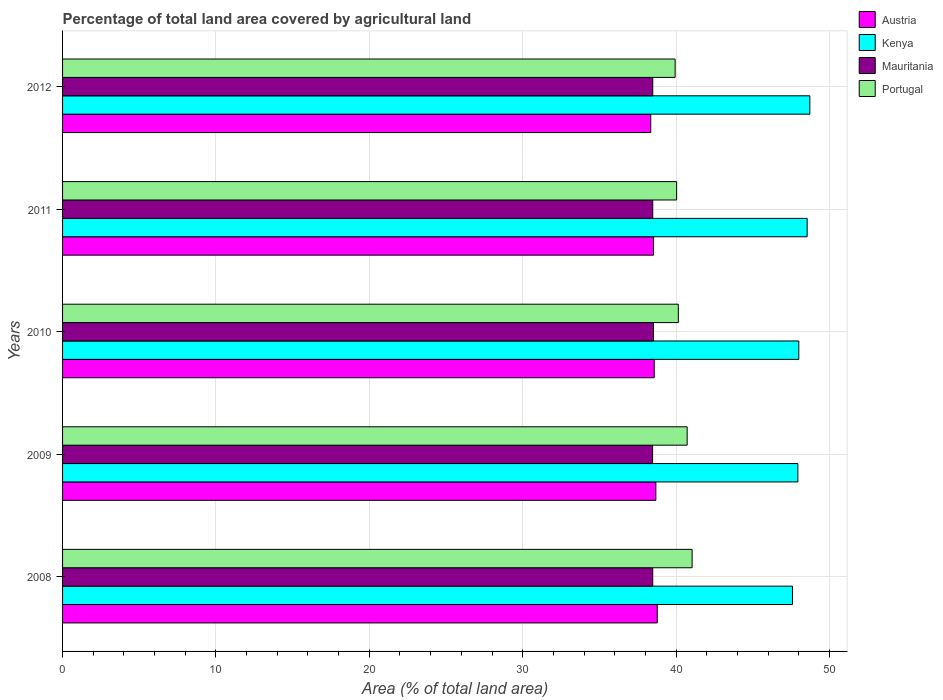How many groups of bars are there?
Provide a succinct answer. 5. How many bars are there on the 2nd tick from the top?
Your answer should be compact. 4. What is the label of the 2nd group of bars from the top?
Your answer should be very brief. 2011. What is the percentage of agricultural land in Mauritania in 2011?
Your answer should be compact. 38.48. Across all years, what is the maximum percentage of agricultural land in Austria?
Ensure brevity in your answer.  38.77. Across all years, what is the minimum percentage of agricultural land in Portugal?
Give a very brief answer. 39.94. In which year was the percentage of agricultural land in Austria minimum?
Keep it short and to the point. 2012. What is the total percentage of agricultural land in Mauritania in the graph?
Make the answer very short. 192.44. What is the difference between the percentage of agricultural land in Portugal in 2010 and that in 2012?
Make the answer very short. 0.21. What is the difference between the percentage of agricultural land in Kenya in 2008 and the percentage of agricultural land in Portugal in 2012?
Your answer should be very brief. 7.65. What is the average percentage of agricultural land in Portugal per year?
Offer a very short reply. 40.38. In the year 2012, what is the difference between the percentage of agricultural land in Portugal and percentage of agricultural land in Mauritania?
Make the answer very short. 1.46. In how many years, is the percentage of agricultural land in Portugal greater than 4 %?
Your response must be concise. 5. What is the ratio of the percentage of agricultural land in Kenya in 2010 to that in 2012?
Your answer should be compact. 0.99. Is the percentage of agricultural land in Austria in 2008 less than that in 2012?
Your response must be concise. No. Is the difference between the percentage of agricultural land in Portugal in 2008 and 2009 greater than the difference between the percentage of agricultural land in Mauritania in 2008 and 2009?
Provide a short and direct response. Yes. What is the difference between the highest and the second highest percentage of agricultural land in Mauritania?
Give a very brief answer. 0.05. What is the difference between the highest and the lowest percentage of agricultural land in Austria?
Your answer should be very brief. 0.42. Is the sum of the percentage of agricultural land in Austria in 2009 and 2011 greater than the maximum percentage of agricultural land in Mauritania across all years?
Provide a short and direct response. Yes. What does the 4th bar from the top in 2010 represents?
Provide a short and direct response. Austria. What does the 2nd bar from the bottom in 2009 represents?
Your answer should be compact. Kenya. What is the difference between two consecutive major ticks on the X-axis?
Offer a very short reply. 10. Are the values on the major ticks of X-axis written in scientific E-notation?
Your answer should be very brief. No. Does the graph contain any zero values?
Your response must be concise. No. How many legend labels are there?
Ensure brevity in your answer.  4. How are the legend labels stacked?
Make the answer very short. Vertical. What is the title of the graph?
Offer a terse response. Percentage of total land area covered by agricultural land. What is the label or title of the X-axis?
Provide a succinct answer. Area (% of total land area). What is the Area (% of total land area) in Austria in 2008?
Your answer should be compact. 38.77. What is the Area (% of total land area) in Kenya in 2008?
Keep it short and to the point. 47.59. What is the Area (% of total land area) in Mauritania in 2008?
Offer a very short reply. 38.48. What is the Area (% of total land area) in Portugal in 2008?
Keep it short and to the point. 41.05. What is the Area (% of total land area) of Austria in 2009?
Your answer should be very brief. 38.68. What is the Area (% of total land area) of Kenya in 2009?
Provide a succinct answer. 47.94. What is the Area (% of total land area) in Mauritania in 2009?
Give a very brief answer. 38.47. What is the Area (% of total land area) of Portugal in 2009?
Offer a very short reply. 40.72. What is the Area (% of total land area) of Austria in 2010?
Your answer should be very brief. 38.58. What is the Area (% of total land area) in Kenya in 2010?
Provide a short and direct response. 48. What is the Area (% of total land area) in Mauritania in 2010?
Provide a succinct answer. 38.53. What is the Area (% of total land area) of Portugal in 2010?
Provide a short and direct response. 40.15. What is the Area (% of total land area) in Austria in 2011?
Your response must be concise. 38.53. What is the Area (% of total land area) in Kenya in 2011?
Keep it short and to the point. 48.55. What is the Area (% of total land area) in Mauritania in 2011?
Keep it short and to the point. 38.48. What is the Area (% of total land area) of Portugal in 2011?
Offer a terse response. 40.04. What is the Area (% of total land area) of Austria in 2012?
Make the answer very short. 38.35. What is the Area (% of total land area) in Kenya in 2012?
Make the answer very short. 48.72. What is the Area (% of total land area) of Mauritania in 2012?
Your answer should be compact. 38.48. What is the Area (% of total land area) in Portugal in 2012?
Make the answer very short. 39.94. Across all years, what is the maximum Area (% of total land area) of Austria?
Keep it short and to the point. 38.77. Across all years, what is the maximum Area (% of total land area) in Kenya?
Offer a very short reply. 48.72. Across all years, what is the maximum Area (% of total land area) of Mauritania?
Your answer should be very brief. 38.53. Across all years, what is the maximum Area (% of total land area) in Portugal?
Your response must be concise. 41.05. Across all years, what is the minimum Area (% of total land area) of Austria?
Offer a terse response. 38.35. Across all years, what is the minimum Area (% of total land area) of Kenya?
Your answer should be very brief. 47.59. Across all years, what is the minimum Area (% of total land area) of Mauritania?
Your response must be concise. 38.47. Across all years, what is the minimum Area (% of total land area) of Portugal?
Provide a succinct answer. 39.94. What is the total Area (% of total land area) in Austria in the graph?
Make the answer very short. 192.91. What is the total Area (% of total land area) of Kenya in the graph?
Offer a terse response. 240.8. What is the total Area (% of total land area) of Mauritania in the graph?
Your answer should be compact. 192.44. What is the total Area (% of total land area) in Portugal in the graph?
Provide a succinct answer. 201.89. What is the difference between the Area (% of total land area) in Austria in 2008 and that in 2009?
Provide a succinct answer. 0.09. What is the difference between the Area (% of total land area) of Kenya in 2008 and that in 2009?
Make the answer very short. -0.35. What is the difference between the Area (% of total land area) of Mauritania in 2008 and that in 2009?
Offer a terse response. 0.01. What is the difference between the Area (% of total land area) of Portugal in 2008 and that in 2009?
Ensure brevity in your answer.  0.32. What is the difference between the Area (% of total land area) in Austria in 2008 and that in 2010?
Offer a terse response. 0.2. What is the difference between the Area (% of total land area) in Kenya in 2008 and that in 2010?
Provide a succinct answer. -0.41. What is the difference between the Area (% of total land area) in Mauritania in 2008 and that in 2010?
Your answer should be compact. -0.05. What is the difference between the Area (% of total land area) of Portugal in 2008 and that in 2010?
Your answer should be very brief. 0.9. What is the difference between the Area (% of total land area) of Austria in 2008 and that in 2011?
Ensure brevity in your answer.  0.24. What is the difference between the Area (% of total land area) of Kenya in 2008 and that in 2011?
Your answer should be very brief. -0.96. What is the difference between the Area (% of total land area) of Mauritania in 2008 and that in 2011?
Your answer should be compact. 0. What is the difference between the Area (% of total land area) of Portugal in 2008 and that in 2011?
Make the answer very short. 1.01. What is the difference between the Area (% of total land area) of Austria in 2008 and that in 2012?
Provide a succinct answer. 0.42. What is the difference between the Area (% of total land area) of Kenya in 2008 and that in 2012?
Offer a terse response. -1.13. What is the difference between the Area (% of total land area) in Mauritania in 2008 and that in 2012?
Provide a short and direct response. 0. What is the difference between the Area (% of total land area) of Portugal in 2008 and that in 2012?
Keep it short and to the point. 1.11. What is the difference between the Area (% of total land area) in Austria in 2009 and that in 2010?
Provide a succinct answer. 0.11. What is the difference between the Area (% of total land area) of Kenya in 2009 and that in 2010?
Your response must be concise. -0.06. What is the difference between the Area (% of total land area) in Mauritania in 2009 and that in 2010?
Ensure brevity in your answer.  -0.06. What is the difference between the Area (% of total land area) in Portugal in 2009 and that in 2010?
Your answer should be very brief. 0.58. What is the difference between the Area (% of total land area) in Austria in 2009 and that in 2011?
Make the answer very short. 0.15. What is the difference between the Area (% of total land area) of Kenya in 2009 and that in 2011?
Offer a terse response. -0.61. What is the difference between the Area (% of total land area) of Mauritania in 2009 and that in 2011?
Your answer should be very brief. -0.01. What is the difference between the Area (% of total land area) in Portugal in 2009 and that in 2011?
Your answer should be compact. 0.69. What is the difference between the Area (% of total land area) in Austria in 2009 and that in 2012?
Offer a terse response. 0.33. What is the difference between the Area (% of total land area) of Kenya in 2009 and that in 2012?
Ensure brevity in your answer.  -0.78. What is the difference between the Area (% of total land area) of Mauritania in 2009 and that in 2012?
Your answer should be compact. -0.01. What is the difference between the Area (% of total land area) in Portugal in 2009 and that in 2012?
Offer a terse response. 0.78. What is the difference between the Area (% of total land area) of Austria in 2010 and that in 2011?
Provide a short and direct response. 0.05. What is the difference between the Area (% of total land area) in Kenya in 2010 and that in 2011?
Offer a terse response. -0.54. What is the difference between the Area (% of total land area) in Mauritania in 2010 and that in 2011?
Give a very brief answer. 0.05. What is the difference between the Area (% of total land area) of Portugal in 2010 and that in 2011?
Give a very brief answer. 0.11. What is the difference between the Area (% of total land area) in Austria in 2010 and that in 2012?
Your answer should be compact. 0.23. What is the difference between the Area (% of total land area) of Kenya in 2010 and that in 2012?
Provide a short and direct response. -0.72. What is the difference between the Area (% of total land area) of Mauritania in 2010 and that in 2012?
Offer a very short reply. 0.05. What is the difference between the Area (% of total land area) in Portugal in 2010 and that in 2012?
Offer a very short reply. 0.21. What is the difference between the Area (% of total land area) in Austria in 2011 and that in 2012?
Give a very brief answer. 0.18. What is the difference between the Area (% of total land area) of Kenya in 2011 and that in 2012?
Offer a very short reply. -0.18. What is the difference between the Area (% of total land area) of Mauritania in 2011 and that in 2012?
Ensure brevity in your answer.  0. What is the difference between the Area (% of total land area) of Portugal in 2011 and that in 2012?
Offer a very short reply. 0.1. What is the difference between the Area (% of total land area) in Austria in 2008 and the Area (% of total land area) in Kenya in 2009?
Your answer should be compact. -9.17. What is the difference between the Area (% of total land area) in Austria in 2008 and the Area (% of total land area) in Mauritania in 2009?
Your response must be concise. 0.3. What is the difference between the Area (% of total land area) of Austria in 2008 and the Area (% of total land area) of Portugal in 2009?
Your response must be concise. -1.95. What is the difference between the Area (% of total land area) of Kenya in 2008 and the Area (% of total land area) of Mauritania in 2009?
Keep it short and to the point. 9.12. What is the difference between the Area (% of total land area) of Kenya in 2008 and the Area (% of total land area) of Portugal in 2009?
Keep it short and to the point. 6.87. What is the difference between the Area (% of total land area) of Mauritania in 2008 and the Area (% of total land area) of Portugal in 2009?
Your response must be concise. -2.24. What is the difference between the Area (% of total land area) of Austria in 2008 and the Area (% of total land area) of Kenya in 2010?
Make the answer very short. -9.23. What is the difference between the Area (% of total land area) of Austria in 2008 and the Area (% of total land area) of Mauritania in 2010?
Give a very brief answer. 0.24. What is the difference between the Area (% of total land area) in Austria in 2008 and the Area (% of total land area) in Portugal in 2010?
Ensure brevity in your answer.  -1.37. What is the difference between the Area (% of total land area) of Kenya in 2008 and the Area (% of total land area) of Mauritania in 2010?
Offer a terse response. 9.06. What is the difference between the Area (% of total land area) in Kenya in 2008 and the Area (% of total land area) in Portugal in 2010?
Make the answer very short. 7.44. What is the difference between the Area (% of total land area) in Mauritania in 2008 and the Area (% of total land area) in Portugal in 2010?
Keep it short and to the point. -1.67. What is the difference between the Area (% of total land area) in Austria in 2008 and the Area (% of total land area) in Kenya in 2011?
Offer a very short reply. -9.77. What is the difference between the Area (% of total land area) in Austria in 2008 and the Area (% of total land area) in Mauritania in 2011?
Offer a very short reply. 0.29. What is the difference between the Area (% of total land area) of Austria in 2008 and the Area (% of total land area) of Portugal in 2011?
Offer a very short reply. -1.26. What is the difference between the Area (% of total land area) of Kenya in 2008 and the Area (% of total land area) of Mauritania in 2011?
Offer a very short reply. 9.11. What is the difference between the Area (% of total land area) of Kenya in 2008 and the Area (% of total land area) of Portugal in 2011?
Offer a very short reply. 7.55. What is the difference between the Area (% of total land area) of Mauritania in 2008 and the Area (% of total land area) of Portugal in 2011?
Ensure brevity in your answer.  -1.56. What is the difference between the Area (% of total land area) in Austria in 2008 and the Area (% of total land area) in Kenya in 2012?
Your response must be concise. -9.95. What is the difference between the Area (% of total land area) of Austria in 2008 and the Area (% of total land area) of Mauritania in 2012?
Keep it short and to the point. 0.29. What is the difference between the Area (% of total land area) of Austria in 2008 and the Area (% of total land area) of Portugal in 2012?
Offer a very short reply. -1.17. What is the difference between the Area (% of total land area) of Kenya in 2008 and the Area (% of total land area) of Mauritania in 2012?
Your answer should be very brief. 9.11. What is the difference between the Area (% of total land area) of Kenya in 2008 and the Area (% of total land area) of Portugal in 2012?
Make the answer very short. 7.65. What is the difference between the Area (% of total land area) of Mauritania in 2008 and the Area (% of total land area) of Portugal in 2012?
Ensure brevity in your answer.  -1.46. What is the difference between the Area (% of total land area) of Austria in 2009 and the Area (% of total land area) of Kenya in 2010?
Offer a terse response. -9.32. What is the difference between the Area (% of total land area) of Austria in 2009 and the Area (% of total land area) of Mauritania in 2010?
Your answer should be very brief. 0.15. What is the difference between the Area (% of total land area) of Austria in 2009 and the Area (% of total land area) of Portugal in 2010?
Provide a short and direct response. -1.46. What is the difference between the Area (% of total land area) of Kenya in 2009 and the Area (% of total land area) of Mauritania in 2010?
Your response must be concise. 9.41. What is the difference between the Area (% of total land area) in Kenya in 2009 and the Area (% of total land area) in Portugal in 2010?
Offer a very short reply. 7.79. What is the difference between the Area (% of total land area) in Mauritania in 2009 and the Area (% of total land area) in Portugal in 2010?
Give a very brief answer. -1.68. What is the difference between the Area (% of total land area) of Austria in 2009 and the Area (% of total land area) of Kenya in 2011?
Your answer should be compact. -9.87. What is the difference between the Area (% of total land area) of Austria in 2009 and the Area (% of total land area) of Mauritania in 2011?
Your response must be concise. 0.2. What is the difference between the Area (% of total land area) in Austria in 2009 and the Area (% of total land area) in Portugal in 2011?
Your answer should be very brief. -1.36. What is the difference between the Area (% of total land area) of Kenya in 2009 and the Area (% of total land area) of Mauritania in 2011?
Make the answer very short. 9.46. What is the difference between the Area (% of total land area) in Kenya in 2009 and the Area (% of total land area) in Portugal in 2011?
Make the answer very short. 7.9. What is the difference between the Area (% of total land area) in Mauritania in 2009 and the Area (% of total land area) in Portugal in 2011?
Offer a very short reply. -1.57. What is the difference between the Area (% of total land area) in Austria in 2009 and the Area (% of total land area) in Kenya in 2012?
Your response must be concise. -10.04. What is the difference between the Area (% of total land area) of Austria in 2009 and the Area (% of total land area) of Mauritania in 2012?
Your response must be concise. 0.2. What is the difference between the Area (% of total land area) in Austria in 2009 and the Area (% of total land area) in Portugal in 2012?
Your answer should be compact. -1.26. What is the difference between the Area (% of total land area) in Kenya in 2009 and the Area (% of total land area) in Mauritania in 2012?
Give a very brief answer. 9.46. What is the difference between the Area (% of total land area) of Kenya in 2009 and the Area (% of total land area) of Portugal in 2012?
Your response must be concise. 8. What is the difference between the Area (% of total land area) of Mauritania in 2009 and the Area (% of total land area) of Portugal in 2012?
Your response must be concise. -1.47. What is the difference between the Area (% of total land area) in Austria in 2010 and the Area (% of total land area) in Kenya in 2011?
Your answer should be compact. -9.97. What is the difference between the Area (% of total land area) in Austria in 2010 and the Area (% of total land area) in Mauritania in 2011?
Your answer should be compact. 0.1. What is the difference between the Area (% of total land area) in Austria in 2010 and the Area (% of total land area) in Portugal in 2011?
Provide a short and direct response. -1.46. What is the difference between the Area (% of total land area) of Kenya in 2010 and the Area (% of total land area) of Mauritania in 2011?
Keep it short and to the point. 9.52. What is the difference between the Area (% of total land area) in Kenya in 2010 and the Area (% of total land area) in Portugal in 2011?
Offer a very short reply. 7.97. What is the difference between the Area (% of total land area) in Mauritania in 2010 and the Area (% of total land area) in Portugal in 2011?
Provide a succinct answer. -1.51. What is the difference between the Area (% of total land area) in Austria in 2010 and the Area (% of total land area) in Kenya in 2012?
Keep it short and to the point. -10.15. What is the difference between the Area (% of total land area) of Austria in 2010 and the Area (% of total land area) of Mauritania in 2012?
Ensure brevity in your answer.  0.1. What is the difference between the Area (% of total land area) in Austria in 2010 and the Area (% of total land area) in Portugal in 2012?
Provide a succinct answer. -1.36. What is the difference between the Area (% of total land area) of Kenya in 2010 and the Area (% of total land area) of Mauritania in 2012?
Offer a terse response. 9.52. What is the difference between the Area (% of total land area) in Kenya in 2010 and the Area (% of total land area) in Portugal in 2012?
Offer a very short reply. 8.06. What is the difference between the Area (% of total land area) in Mauritania in 2010 and the Area (% of total land area) in Portugal in 2012?
Your answer should be compact. -1.41. What is the difference between the Area (% of total land area) in Austria in 2011 and the Area (% of total land area) in Kenya in 2012?
Your response must be concise. -10.19. What is the difference between the Area (% of total land area) in Austria in 2011 and the Area (% of total land area) in Mauritania in 2012?
Ensure brevity in your answer.  0.05. What is the difference between the Area (% of total land area) in Austria in 2011 and the Area (% of total land area) in Portugal in 2012?
Offer a terse response. -1.41. What is the difference between the Area (% of total land area) in Kenya in 2011 and the Area (% of total land area) in Mauritania in 2012?
Your answer should be compact. 10.07. What is the difference between the Area (% of total land area) in Kenya in 2011 and the Area (% of total land area) in Portugal in 2012?
Your response must be concise. 8.61. What is the difference between the Area (% of total land area) of Mauritania in 2011 and the Area (% of total land area) of Portugal in 2012?
Your answer should be very brief. -1.46. What is the average Area (% of total land area) in Austria per year?
Ensure brevity in your answer.  38.58. What is the average Area (% of total land area) of Kenya per year?
Ensure brevity in your answer.  48.16. What is the average Area (% of total land area) in Mauritania per year?
Provide a succinct answer. 38.49. What is the average Area (% of total land area) in Portugal per year?
Offer a terse response. 40.38. In the year 2008, what is the difference between the Area (% of total land area) in Austria and Area (% of total land area) in Kenya?
Keep it short and to the point. -8.82. In the year 2008, what is the difference between the Area (% of total land area) of Austria and Area (% of total land area) of Mauritania?
Your response must be concise. 0.29. In the year 2008, what is the difference between the Area (% of total land area) in Austria and Area (% of total land area) in Portugal?
Offer a terse response. -2.27. In the year 2008, what is the difference between the Area (% of total land area) in Kenya and Area (% of total land area) in Mauritania?
Ensure brevity in your answer.  9.11. In the year 2008, what is the difference between the Area (% of total land area) in Kenya and Area (% of total land area) in Portugal?
Offer a very short reply. 6.54. In the year 2008, what is the difference between the Area (% of total land area) in Mauritania and Area (% of total land area) in Portugal?
Your answer should be very brief. -2.57. In the year 2009, what is the difference between the Area (% of total land area) of Austria and Area (% of total land area) of Kenya?
Give a very brief answer. -9.26. In the year 2009, what is the difference between the Area (% of total land area) in Austria and Area (% of total land area) in Mauritania?
Provide a succinct answer. 0.21. In the year 2009, what is the difference between the Area (% of total land area) of Austria and Area (% of total land area) of Portugal?
Make the answer very short. -2.04. In the year 2009, what is the difference between the Area (% of total land area) in Kenya and Area (% of total land area) in Mauritania?
Give a very brief answer. 9.47. In the year 2009, what is the difference between the Area (% of total land area) of Kenya and Area (% of total land area) of Portugal?
Ensure brevity in your answer.  7.22. In the year 2009, what is the difference between the Area (% of total land area) of Mauritania and Area (% of total land area) of Portugal?
Offer a very short reply. -2.25. In the year 2010, what is the difference between the Area (% of total land area) in Austria and Area (% of total land area) in Kenya?
Give a very brief answer. -9.43. In the year 2010, what is the difference between the Area (% of total land area) of Austria and Area (% of total land area) of Mauritania?
Make the answer very short. 0.05. In the year 2010, what is the difference between the Area (% of total land area) of Austria and Area (% of total land area) of Portugal?
Your response must be concise. -1.57. In the year 2010, what is the difference between the Area (% of total land area) in Kenya and Area (% of total land area) in Mauritania?
Offer a very short reply. 9.47. In the year 2010, what is the difference between the Area (% of total land area) of Kenya and Area (% of total land area) of Portugal?
Provide a succinct answer. 7.86. In the year 2010, what is the difference between the Area (% of total land area) of Mauritania and Area (% of total land area) of Portugal?
Offer a terse response. -1.62. In the year 2011, what is the difference between the Area (% of total land area) in Austria and Area (% of total land area) in Kenya?
Your response must be concise. -10.02. In the year 2011, what is the difference between the Area (% of total land area) of Austria and Area (% of total land area) of Mauritania?
Make the answer very short. 0.05. In the year 2011, what is the difference between the Area (% of total land area) of Austria and Area (% of total land area) of Portugal?
Offer a terse response. -1.51. In the year 2011, what is the difference between the Area (% of total land area) of Kenya and Area (% of total land area) of Mauritania?
Ensure brevity in your answer.  10.07. In the year 2011, what is the difference between the Area (% of total land area) in Kenya and Area (% of total land area) in Portugal?
Your answer should be compact. 8.51. In the year 2011, what is the difference between the Area (% of total land area) of Mauritania and Area (% of total land area) of Portugal?
Offer a very short reply. -1.56. In the year 2012, what is the difference between the Area (% of total land area) of Austria and Area (% of total land area) of Kenya?
Your answer should be very brief. -10.37. In the year 2012, what is the difference between the Area (% of total land area) of Austria and Area (% of total land area) of Mauritania?
Your answer should be compact. -0.13. In the year 2012, what is the difference between the Area (% of total land area) of Austria and Area (% of total land area) of Portugal?
Offer a terse response. -1.59. In the year 2012, what is the difference between the Area (% of total land area) in Kenya and Area (% of total land area) in Mauritania?
Your answer should be very brief. 10.24. In the year 2012, what is the difference between the Area (% of total land area) of Kenya and Area (% of total land area) of Portugal?
Your response must be concise. 8.78. In the year 2012, what is the difference between the Area (% of total land area) in Mauritania and Area (% of total land area) in Portugal?
Keep it short and to the point. -1.46. What is the ratio of the Area (% of total land area) of Austria in 2008 to that in 2009?
Ensure brevity in your answer.  1. What is the ratio of the Area (% of total land area) in Portugal in 2008 to that in 2009?
Provide a succinct answer. 1.01. What is the ratio of the Area (% of total land area) in Austria in 2008 to that in 2010?
Provide a short and direct response. 1.01. What is the ratio of the Area (% of total land area) of Kenya in 2008 to that in 2010?
Provide a succinct answer. 0.99. What is the ratio of the Area (% of total land area) in Portugal in 2008 to that in 2010?
Keep it short and to the point. 1.02. What is the ratio of the Area (% of total land area) of Kenya in 2008 to that in 2011?
Ensure brevity in your answer.  0.98. What is the ratio of the Area (% of total land area) of Mauritania in 2008 to that in 2011?
Your response must be concise. 1. What is the ratio of the Area (% of total land area) of Portugal in 2008 to that in 2011?
Keep it short and to the point. 1.03. What is the ratio of the Area (% of total land area) of Austria in 2008 to that in 2012?
Offer a very short reply. 1.01. What is the ratio of the Area (% of total land area) of Kenya in 2008 to that in 2012?
Offer a terse response. 0.98. What is the ratio of the Area (% of total land area) of Mauritania in 2008 to that in 2012?
Ensure brevity in your answer.  1. What is the ratio of the Area (% of total land area) of Portugal in 2008 to that in 2012?
Your answer should be very brief. 1.03. What is the ratio of the Area (% of total land area) in Austria in 2009 to that in 2010?
Ensure brevity in your answer.  1. What is the ratio of the Area (% of total land area) of Kenya in 2009 to that in 2010?
Give a very brief answer. 1. What is the ratio of the Area (% of total land area) of Mauritania in 2009 to that in 2010?
Ensure brevity in your answer.  1. What is the ratio of the Area (% of total land area) in Portugal in 2009 to that in 2010?
Give a very brief answer. 1.01. What is the ratio of the Area (% of total land area) in Kenya in 2009 to that in 2011?
Offer a terse response. 0.99. What is the ratio of the Area (% of total land area) in Portugal in 2009 to that in 2011?
Ensure brevity in your answer.  1.02. What is the ratio of the Area (% of total land area) in Austria in 2009 to that in 2012?
Offer a terse response. 1.01. What is the ratio of the Area (% of total land area) of Portugal in 2009 to that in 2012?
Your answer should be compact. 1.02. What is the ratio of the Area (% of total land area) in Austria in 2010 to that in 2011?
Ensure brevity in your answer.  1. What is the ratio of the Area (% of total land area) of Kenya in 2010 to that in 2011?
Your answer should be compact. 0.99. What is the ratio of the Area (% of total land area) in Mauritania in 2010 to that in 2011?
Give a very brief answer. 1. What is the ratio of the Area (% of total land area) in Portugal in 2010 to that in 2011?
Keep it short and to the point. 1. What is the ratio of the Area (% of total land area) of Austria in 2010 to that in 2012?
Offer a very short reply. 1.01. What is the ratio of the Area (% of total land area) of Kenya in 2010 to that in 2012?
Your response must be concise. 0.99. What is the ratio of the Area (% of total land area) of Mauritania in 2010 to that in 2012?
Offer a terse response. 1. What is the ratio of the Area (% of total land area) of Austria in 2011 to that in 2012?
Provide a short and direct response. 1. What is the ratio of the Area (% of total land area) of Portugal in 2011 to that in 2012?
Ensure brevity in your answer.  1. What is the difference between the highest and the second highest Area (% of total land area) in Austria?
Your answer should be compact. 0.09. What is the difference between the highest and the second highest Area (% of total land area) in Kenya?
Make the answer very short. 0.18. What is the difference between the highest and the second highest Area (% of total land area) in Mauritania?
Make the answer very short. 0.05. What is the difference between the highest and the second highest Area (% of total land area) in Portugal?
Offer a terse response. 0.32. What is the difference between the highest and the lowest Area (% of total land area) in Austria?
Provide a succinct answer. 0.42. What is the difference between the highest and the lowest Area (% of total land area) in Kenya?
Make the answer very short. 1.13. What is the difference between the highest and the lowest Area (% of total land area) in Mauritania?
Offer a very short reply. 0.06. What is the difference between the highest and the lowest Area (% of total land area) in Portugal?
Provide a succinct answer. 1.11. 